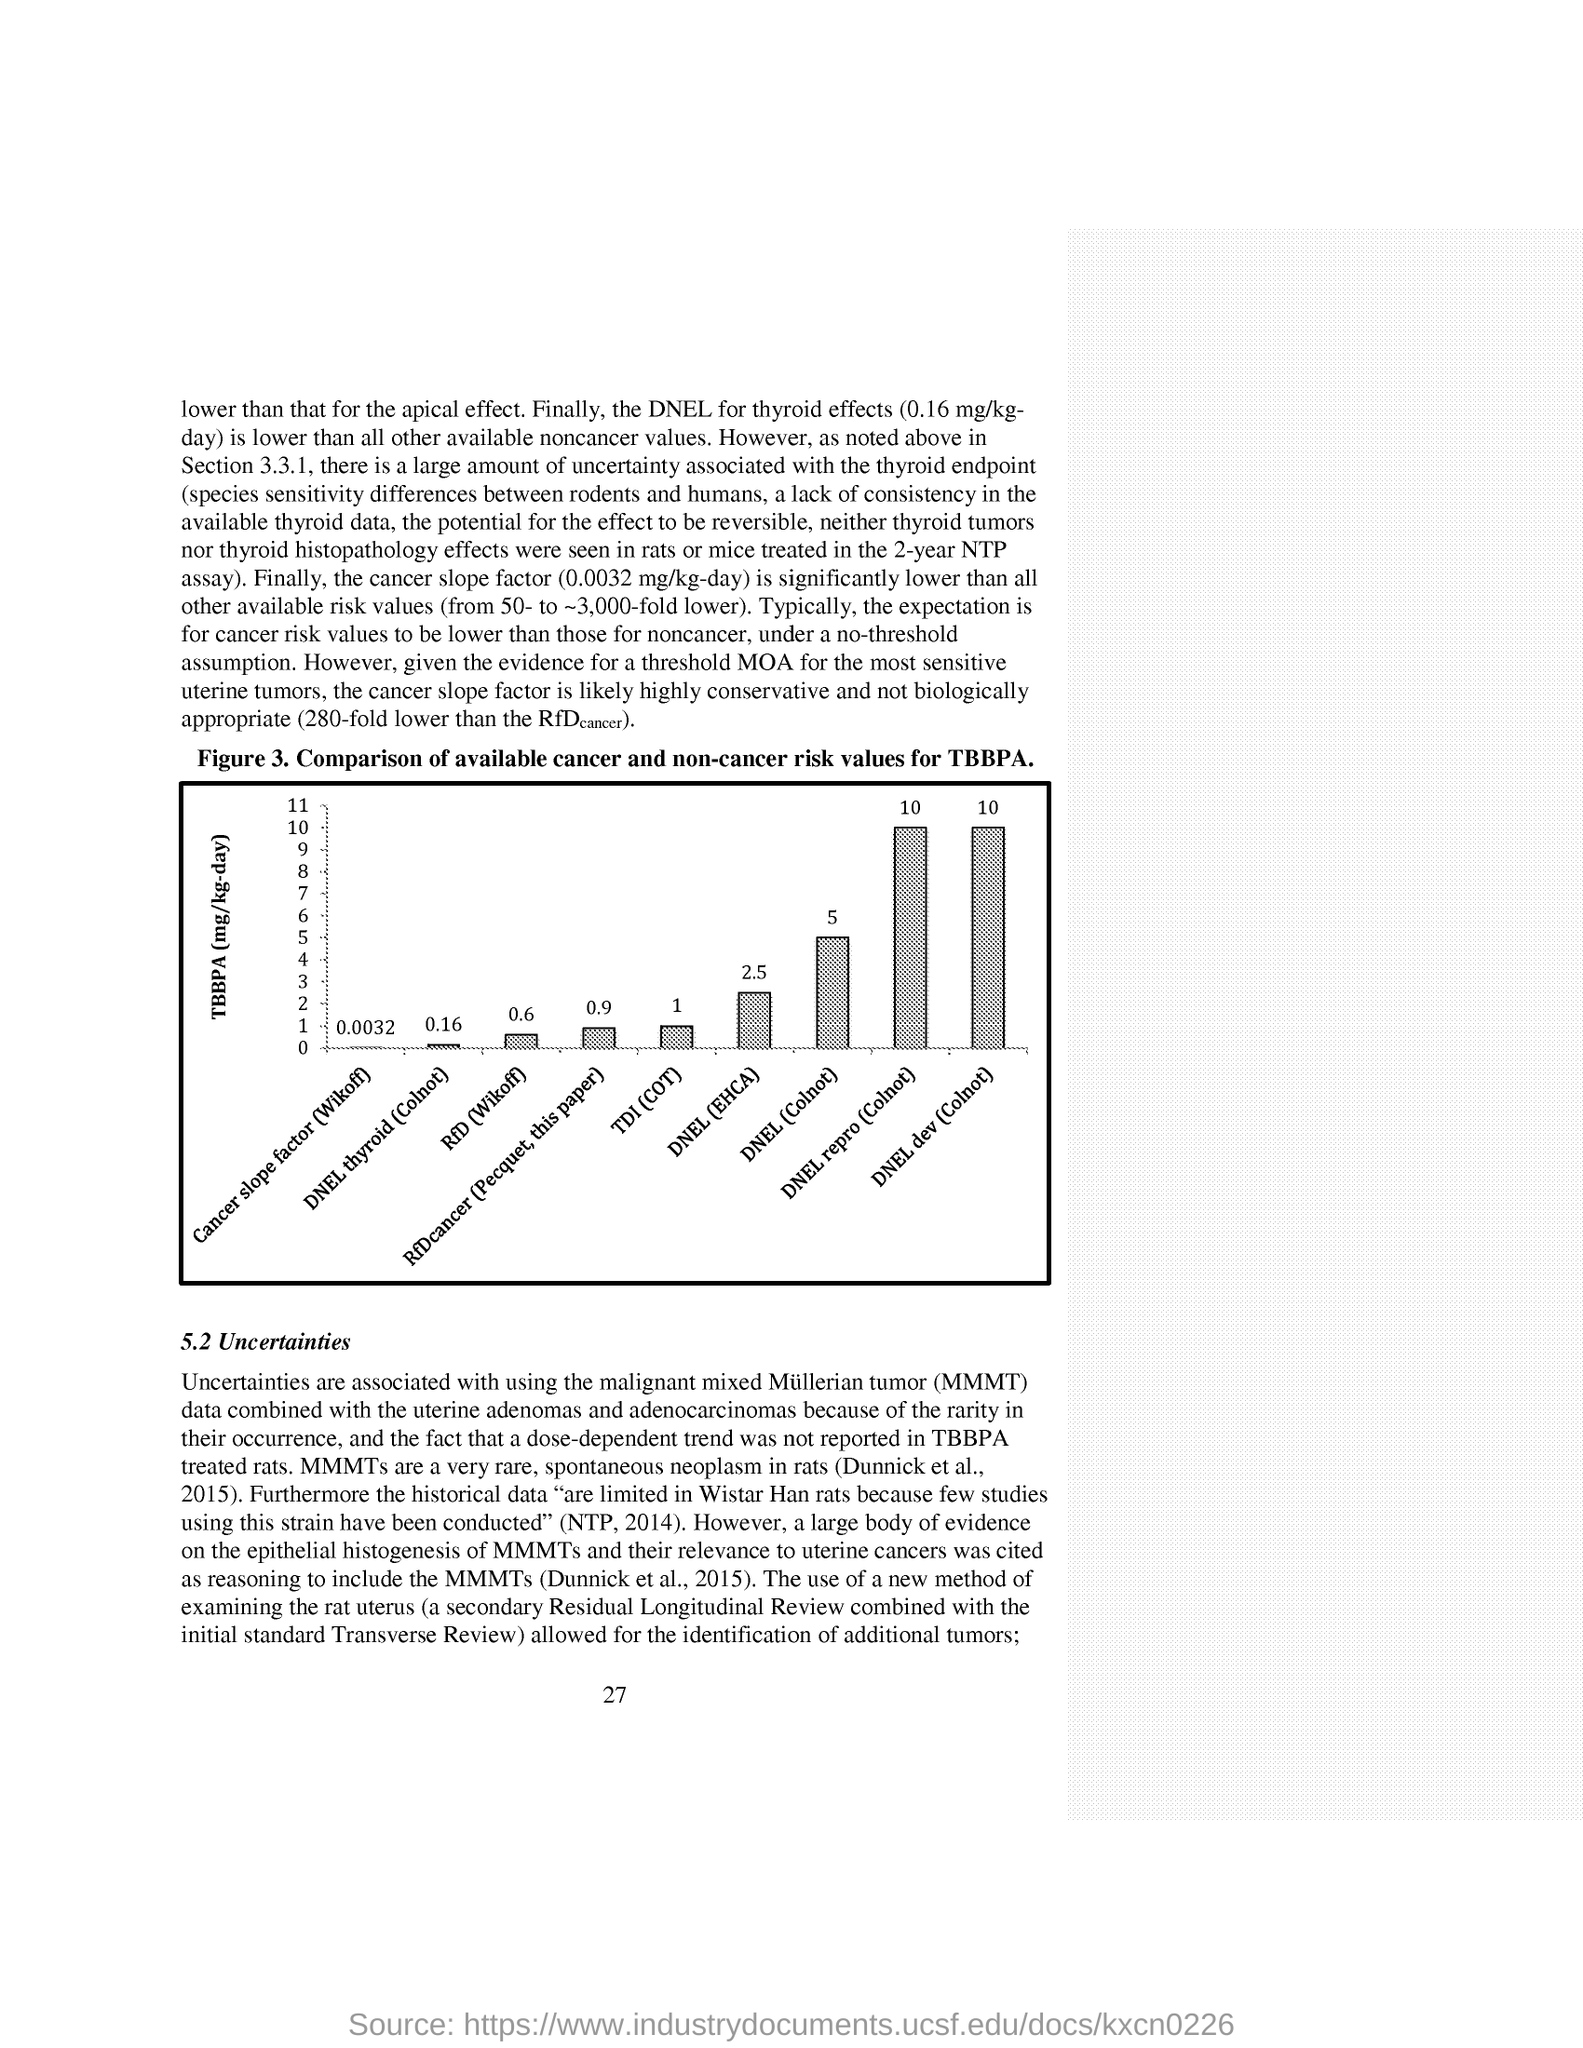Specify some key components in this picture. The TBBPA is expressed in terms of milligrams per kilogram per day (mg/kg-day). The cancer slope factor, which is defined as 0.0032 mg/kg-day, is significantly lower than all other available risk values, ranging from 50- to approximately 3,000-fold lower. The DNEL (Derived No Effect Level) for the dev (Colnot) scenario is shown in the flowchart, with a percentage range of 10-15%. 